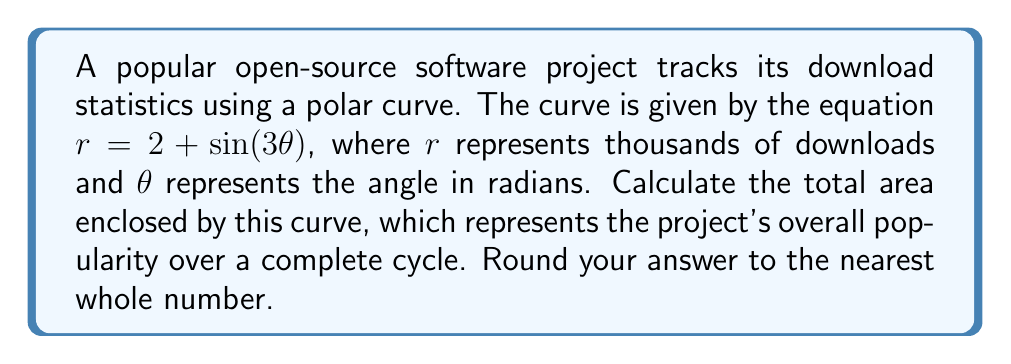Can you solve this math problem? To solve this problem, we'll follow these steps:

1) The formula for the area enclosed by a polar curve is:

   $$A = \frac{1}{2} \int_0^{2\pi} r^2 d\theta$$

2) Substitute our equation $r = 2 + \sin(3\theta)$ into this formula:

   $$A = \frac{1}{2} \int_0^{2\pi} (2 + \sin(3\theta))^2 d\theta$$

3) Expand the squared term:

   $$A = \frac{1}{2} \int_0^{2\pi} (4 + 4\sin(3\theta) + \sin^2(3\theta)) d\theta$$

4) Integrate each term:

   $$A = \frac{1}{2} [4\theta + \frac{4}{3}\cos(3\theta) + \frac{\theta}{2} - \frac{\sin(6\theta)}{12}]_0^{2\pi}$$

5) Evaluate at the limits:

   $$A = \frac{1}{2} [(4(2\pi) + \frac{4}{3}(\cos(6\pi) - \cos(0)) + \frac{2\pi}{2} - \frac{1}{12}(\sin(12\pi) - \sin(0))]$$

6) Simplify:

   $$A = \frac{1}{2} [8\pi + 0 + \pi + 0] = \frac{9\pi}{2}$$

7) This result is in terms of square units of $r$. Since $r$ represents thousands of downloads, we need to multiply by 1000^2 to get the actual number of downloads.

   $$A_{actual} = \frac{9\pi}{2} * 1000^2 = 4,500,000\pi$$

8) Rounding to the nearest whole number:

   $$A_{rounded} \approx 14,137,167$$
Answer: 14,137,167 downloads 